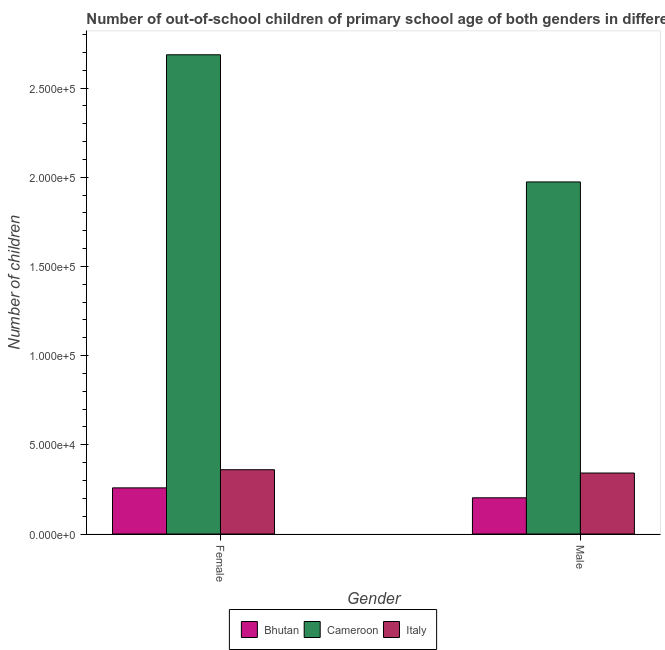How many different coloured bars are there?
Make the answer very short. 3. Are the number of bars per tick equal to the number of legend labels?
Provide a succinct answer. Yes. Are the number of bars on each tick of the X-axis equal?
Your answer should be compact. Yes. How many bars are there on the 1st tick from the right?
Your response must be concise. 3. What is the label of the 2nd group of bars from the left?
Give a very brief answer. Male. What is the number of male out-of-school students in Cameroon?
Ensure brevity in your answer.  1.97e+05. Across all countries, what is the maximum number of male out-of-school students?
Your answer should be very brief. 1.97e+05. Across all countries, what is the minimum number of female out-of-school students?
Provide a succinct answer. 2.59e+04. In which country was the number of female out-of-school students maximum?
Ensure brevity in your answer.  Cameroon. In which country was the number of male out-of-school students minimum?
Make the answer very short. Bhutan. What is the total number of female out-of-school students in the graph?
Keep it short and to the point. 3.31e+05. What is the difference between the number of male out-of-school students in Cameroon and that in Bhutan?
Your response must be concise. 1.77e+05. What is the difference between the number of female out-of-school students in Bhutan and the number of male out-of-school students in Cameroon?
Your response must be concise. -1.71e+05. What is the average number of male out-of-school students per country?
Give a very brief answer. 8.39e+04. What is the difference between the number of male out-of-school students and number of female out-of-school students in Cameroon?
Offer a very short reply. -7.13e+04. What is the ratio of the number of male out-of-school students in Bhutan to that in Italy?
Your answer should be very brief. 0.59. Is the number of female out-of-school students in Cameroon less than that in Bhutan?
Your answer should be very brief. No. What does the 1st bar from the left in Female represents?
Give a very brief answer. Bhutan. What does the 2nd bar from the right in Female represents?
Offer a terse response. Cameroon. How many bars are there?
Provide a short and direct response. 6. Are all the bars in the graph horizontal?
Make the answer very short. No. Does the graph contain grids?
Ensure brevity in your answer.  No. Where does the legend appear in the graph?
Ensure brevity in your answer.  Bottom center. How many legend labels are there?
Keep it short and to the point. 3. How are the legend labels stacked?
Your answer should be compact. Horizontal. What is the title of the graph?
Give a very brief answer. Number of out-of-school children of primary school age of both genders in different countries. What is the label or title of the X-axis?
Give a very brief answer. Gender. What is the label or title of the Y-axis?
Your answer should be very brief. Number of children. What is the Number of children of Bhutan in Female?
Your answer should be very brief. 2.59e+04. What is the Number of children in Cameroon in Female?
Make the answer very short. 2.69e+05. What is the Number of children of Italy in Female?
Keep it short and to the point. 3.60e+04. What is the Number of children of Bhutan in Male?
Give a very brief answer. 2.03e+04. What is the Number of children in Cameroon in Male?
Ensure brevity in your answer.  1.97e+05. What is the Number of children in Italy in Male?
Give a very brief answer. 3.42e+04. Across all Gender, what is the maximum Number of children in Bhutan?
Your answer should be compact. 2.59e+04. Across all Gender, what is the maximum Number of children of Cameroon?
Make the answer very short. 2.69e+05. Across all Gender, what is the maximum Number of children in Italy?
Offer a terse response. 3.60e+04. Across all Gender, what is the minimum Number of children of Bhutan?
Your answer should be very brief. 2.03e+04. Across all Gender, what is the minimum Number of children in Cameroon?
Provide a succinct answer. 1.97e+05. Across all Gender, what is the minimum Number of children of Italy?
Make the answer very short. 3.42e+04. What is the total Number of children in Bhutan in the graph?
Provide a succinct answer. 4.61e+04. What is the total Number of children of Cameroon in the graph?
Offer a terse response. 4.66e+05. What is the total Number of children of Italy in the graph?
Make the answer very short. 7.02e+04. What is the difference between the Number of children of Bhutan in Female and that in Male?
Offer a very short reply. 5570. What is the difference between the Number of children of Cameroon in Female and that in Male?
Give a very brief answer. 7.13e+04. What is the difference between the Number of children in Italy in Female and that in Male?
Ensure brevity in your answer.  1849. What is the difference between the Number of children of Bhutan in Female and the Number of children of Cameroon in Male?
Give a very brief answer. -1.71e+05. What is the difference between the Number of children of Bhutan in Female and the Number of children of Italy in Male?
Ensure brevity in your answer.  -8325. What is the difference between the Number of children of Cameroon in Female and the Number of children of Italy in Male?
Give a very brief answer. 2.34e+05. What is the average Number of children of Bhutan per Gender?
Keep it short and to the point. 2.31e+04. What is the average Number of children of Cameroon per Gender?
Your answer should be compact. 2.33e+05. What is the average Number of children in Italy per Gender?
Give a very brief answer. 3.51e+04. What is the difference between the Number of children in Bhutan and Number of children in Cameroon in Female?
Provide a succinct answer. -2.43e+05. What is the difference between the Number of children of Bhutan and Number of children of Italy in Female?
Make the answer very short. -1.02e+04. What is the difference between the Number of children in Cameroon and Number of children in Italy in Female?
Give a very brief answer. 2.33e+05. What is the difference between the Number of children of Bhutan and Number of children of Cameroon in Male?
Your answer should be compact. -1.77e+05. What is the difference between the Number of children in Bhutan and Number of children in Italy in Male?
Offer a terse response. -1.39e+04. What is the difference between the Number of children in Cameroon and Number of children in Italy in Male?
Provide a short and direct response. 1.63e+05. What is the ratio of the Number of children of Bhutan in Female to that in Male?
Your response must be concise. 1.27. What is the ratio of the Number of children of Cameroon in Female to that in Male?
Ensure brevity in your answer.  1.36. What is the ratio of the Number of children of Italy in Female to that in Male?
Your answer should be compact. 1.05. What is the difference between the highest and the second highest Number of children in Bhutan?
Make the answer very short. 5570. What is the difference between the highest and the second highest Number of children in Cameroon?
Provide a succinct answer. 7.13e+04. What is the difference between the highest and the second highest Number of children in Italy?
Your response must be concise. 1849. What is the difference between the highest and the lowest Number of children in Bhutan?
Ensure brevity in your answer.  5570. What is the difference between the highest and the lowest Number of children in Cameroon?
Offer a very short reply. 7.13e+04. What is the difference between the highest and the lowest Number of children in Italy?
Your answer should be very brief. 1849. 